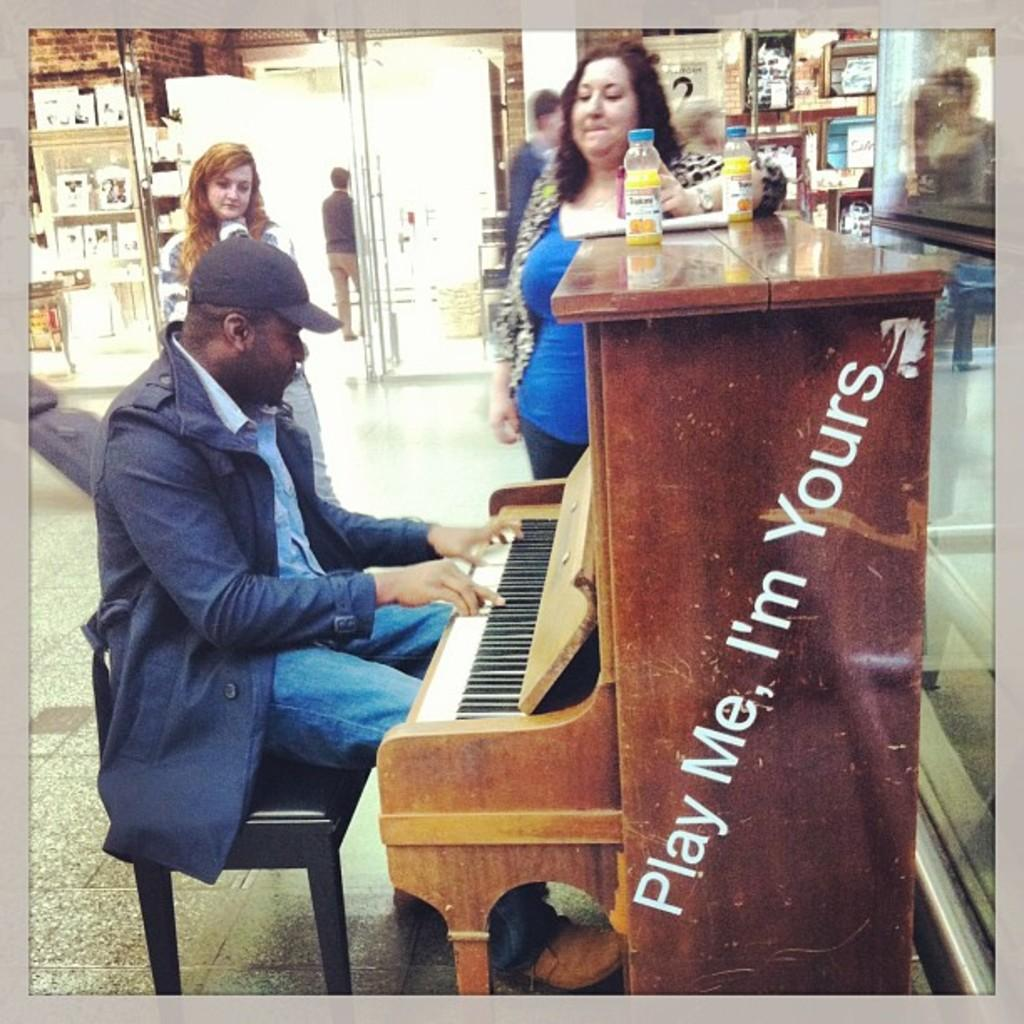What is the person in the image doing? The person is sitting on a wooden chair and playing a piano. Can you describe the position of the woman in the image? The woman is standing in the center of the image. What is the woman looking at? The woman is looking at the person playing the piano. What type of berry is the woman holding in her hand in the image? There is no berry present in the image; the woman is not holding anything in her hand. 